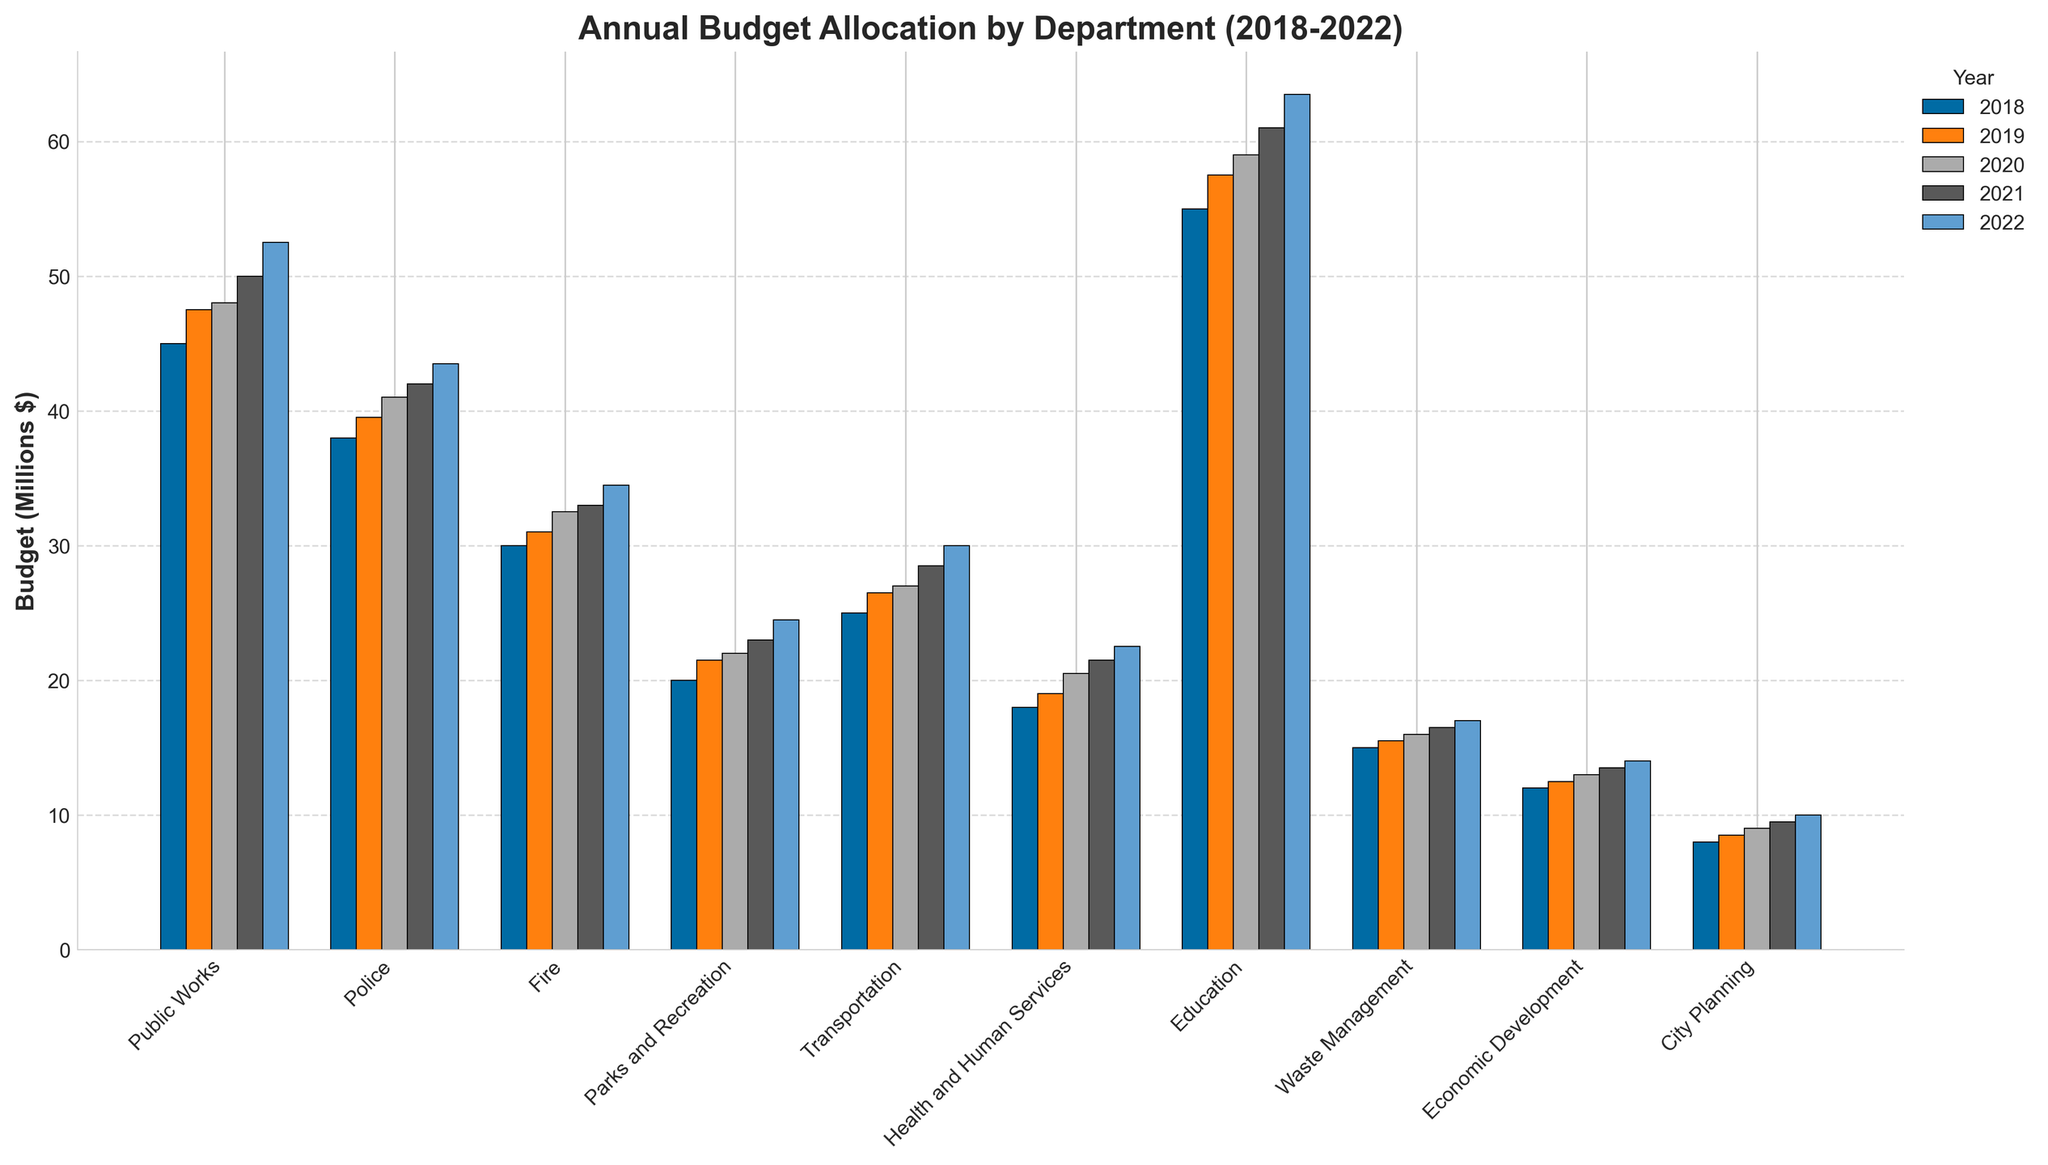Which department received the highest budget allocation in 2022? By examining the bar heights in the 2022 section of the graph, the Education department has the tallest bar, indicating the highest budget allocation.
Answer: Education What is the total budget allocated to Public Works over the 5-year period? Sum the budget values for Public Works across 2018-2022: 45000000 + 47500000 + 48000000 + 50000000 + 52500000 = 243000000.
Answer: 243 million dollars How does the 2020 budget for Health and Human Services compare to that of Waste Management? Identify the bars for Health and Human Services and Waste Management in 2020. Health and Human Services has a taller bar (20500000) compared to Waste Management (16000000).
Answer: Health and Human Services has a higher budget Which year saw the highest budget increase for the Fire department compared to the previous year? Examine the differences in Fire department budgets year over year. The largest increase is from 2019 to 2020 (32500000 - 31000000 = 1500000).
Answer: 2020 What is the average annual budget for the Transportation department from 2018 to 2022? Sum the budget values for Transportation over the 5 years and divide by 5: (25000000 + 26500000 + 27000000 + 28500000 + 30000000)/5 = 137.5 million /5 = 27.5 million.
Answer: 27.5 million dollars How much more funding did Education receive in 2022 compared to 2018? Subtract the 2018 budget for Education from the 2022 budget: 63500000 - 55000000 = 8500000.
Answer: 8.5 million dollars Which department consistently saw an increase in their budget every year from 2018 to 2022? By examining the trend over the years, several departments have shown consistent increases, but the Education department stands out with increasing budgets each year.
Answer: Education Compare the budgets of the Police and Fire departments in 2021. Which department received higher funding and by how much? The Police department had a budget of 42000000 while the Fire department had 33000000 in 2021. The difference is 42000000 - 33000000 = 9000000.
Answer: Police, 9 million dollars If you sum the 2022 budgets for Parks and Recreation, City Planning, and Economic Development, what is the total? Add the 2022 budgets for the three departments: 24500000 + 10000000 + 14000000 = 48500000.
Answer: 48.5 million dollars What was the percentage increase in the budget for Parks and Recreation from 2018 to 2022? Calculate the difference and then the percentage increase: (24500000 - 20000000) / 20000000 * 100 = 22.5%.
Answer: 22.5% 